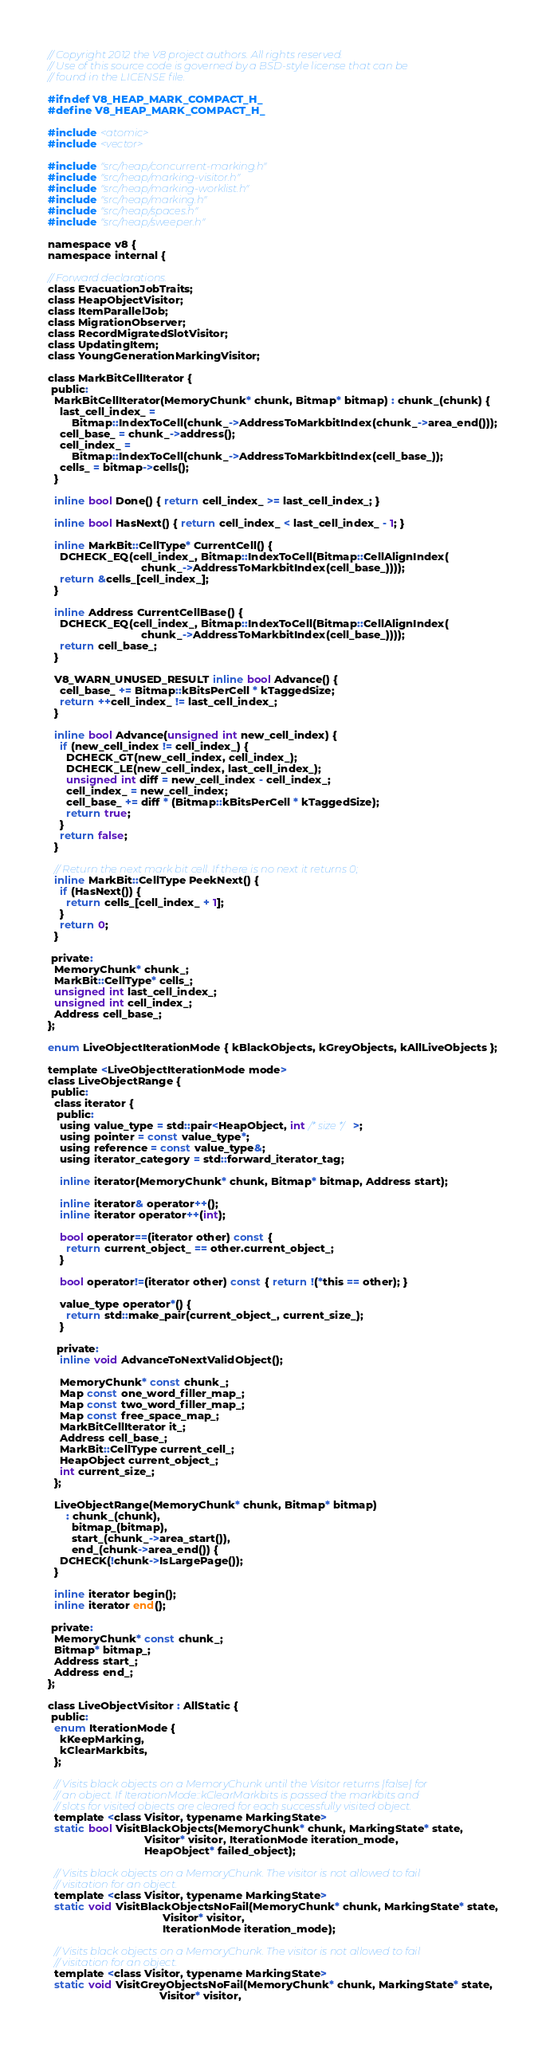Convert code to text. <code><loc_0><loc_0><loc_500><loc_500><_C_>// Copyright 2012 the V8 project authors. All rights reserved.
// Use of this source code is governed by a BSD-style license that can be
// found in the LICENSE file.

#ifndef V8_HEAP_MARK_COMPACT_H_
#define V8_HEAP_MARK_COMPACT_H_

#include <atomic>
#include <vector>

#include "src/heap/concurrent-marking.h"
#include "src/heap/marking-visitor.h"
#include "src/heap/marking-worklist.h"
#include "src/heap/marking.h"
#include "src/heap/spaces.h"
#include "src/heap/sweeper.h"

namespace v8 {
namespace internal {

// Forward declarations.
class EvacuationJobTraits;
class HeapObjectVisitor;
class ItemParallelJob;
class MigrationObserver;
class RecordMigratedSlotVisitor;
class UpdatingItem;
class YoungGenerationMarkingVisitor;

class MarkBitCellIterator {
 public:
  MarkBitCellIterator(MemoryChunk* chunk, Bitmap* bitmap) : chunk_(chunk) {
    last_cell_index_ =
        Bitmap::IndexToCell(chunk_->AddressToMarkbitIndex(chunk_->area_end()));
    cell_base_ = chunk_->address();
    cell_index_ =
        Bitmap::IndexToCell(chunk_->AddressToMarkbitIndex(cell_base_));
    cells_ = bitmap->cells();
  }

  inline bool Done() { return cell_index_ >= last_cell_index_; }

  inline bool HasNext() { return cell_index_ < last_cell_index_ - 1; }

  inline MarkBit::CellType* CurrentCell() {
    DCHECK_EQ(cell_index_, Bitmap::IndexToCell(Bitmap::CellAlignIndex(
                               chunk_->AddressToMarkbitIndex(cell_base_))));
    return &cells_[cell_index_];
  }

  inline Address CurrentCellBase() {
    DCHECK_EQ(cell_index_, Bitmap::IndexToCell(Bitmap::CellAlignIndex(
                               chunk_->AddressToMarkbitIndex(cell_base_))));
    return cell_base_;
  }

  V8_WARN_UNUSED_RESULT inline bool Advance() {
    cell_base_ += Bitmap::kBitsPerCell * kTaggedSize;
    return ++cell_index_ != last_cell_index_;
  }

  inline bool Advance(unsigned int new_cell_index) {
    if (new_cell_index != cell_index_) {
      DCHECK_GT(new_cell_index, cell_index_);
      DCHECK_LE(new_cell_index, last_cell_index_);
      unsigned int diff = new_cell_index - cell_index_;
      cell_index_ = new_cell_index;
      cell_base_ += diff * (Bitmap::kBitsPerCell * kTaggedSize);
      return true;
    }
    return false;
  }

  // Return the next mark bit cell. If there is no next it returns 0;
  inline MarkBit::CellType PeekNext() {
    if (HasNext()) {
      return cells_[cell_index_ + 1];
    }
    return 0;
  }

 private:
  MemoryChunk* chunk_;
  MarkBit::CellType* cells_;
  unsigned int last_cell_index_;
  unsigned int cell_index_;
  Address cell_base_;
};

enum LiveObjectIterationMode { kBlackObjects, kGreyObjects, kAllLiveObjects };

template <LiveObjectIterationMode mode>
class LiveObjectRange {
 public:
  class iterator {
   public:
    using value_type = std::pair<HeapObject, int /* size */>;
    using pointer = const value_type*;
    using reference = const value_type&;
    using iterator_category = std::forward_iterator_tag;

    inline iterator(MemoryChunk* chunk, Bitmap* bitmap, Address start);

    inline iterator& operator++();
    inline iterator operator++(int);

    bool operator==(iterator other) const {
      return current_object_ == other.current_object_;
    }

    bool operator!=(iterator other) const { return !(*this == other); }

    value_type operator*() {
      return std::make_pair(current_object_, current_size_);
    }

   private:
    inline void AdvanceToNextValidObject();

    MemoryChunk* const chunk_;
    Map const one_word_filler_map_;
    Map const two_word_filler_map_;
    Map const free_space_map_;
    MarkBitCellIterator it_;
    Address cell_base_;
    MarkBit::CellType current_cell_;
    HeapObject current_object_;
    int current_size_;
  };

  LiveObjectRange(MemoryChunk* chunk, Bitmap* bitmap)
      : chunk_(chunk),
        bitmap_(bitmap),
        start_(chunk_->area_start()),
        end_(chunk->area_end()) {
    DCHECK(!chunk->IsLargePage());
  }

  inline iterator begin();
  inline iterator end();

 private:
  MemoryChunk* const chunk_;
  Bitmap* bitmap_;
  Address start_;
  Address end_;
};

class LiveObjectVisitor : AllStatic {
 public:
  enum IterationMode {
    kKeepMarking,
    kClearMarkbits,
  };

  // Visits black objects on a MemoryChunk until the Visitor returns |false| for
  // an object. If IterationMode::kClearMarkbits is passed the markbits and
  // slots for visited objects are cleared for each successfully visited object.
  template <class Visitor, typename MarkingState>
  static bool VisitBlackObjects(MemoryChunk* chunk, MarkingState* state,
                                Visitor* visitor, IterationMode iteration_mode,
                                HeapObject* failed_object);

  // Visits black objects on a MemoryChunk. The visitor is not allowed to fail
  // visitation for an object.
  template <class Visitor, typename MarkingState>
  static void VisitBlackObjectsNoFail(MemoryChunk* chunk, MarkingState* state,
                                      Visitor* visitor,
                                      IterationMode iteration_mode);

  // Visits black objects on a MemoryChunk. The visitor is not allowed to fail
  // visitation for an object.
  template <class Visitor, typename MarkingState>
  static void VisitGreyObjectsNoFail(MemoryChunk* chunk, MarkingState* state,
                                     Visitor* visitor,</code> 